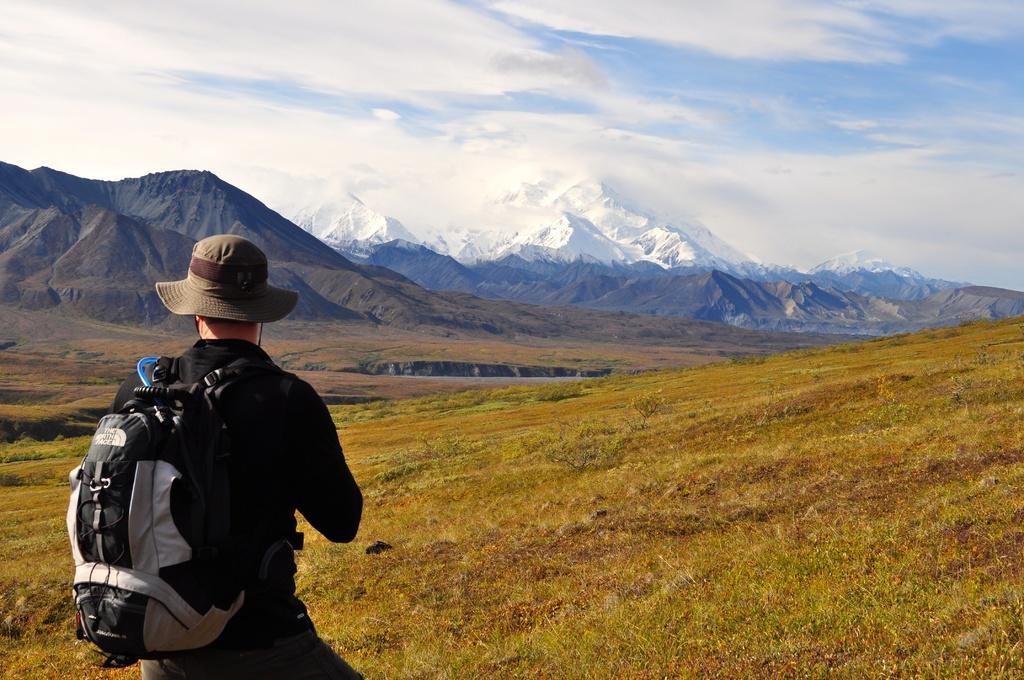Can you describe this image briefly? In this picture we can see person wore cap carrying bag and standing on grass and in background we can see mountains, sky with clouds. 